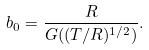Convert formula to latex. <formula><loc_0><loc_0><loc_500><loc_500>b _ { 0 } = \frac { R } { G ( ( T / R ) ^ { 1 / 2 } ) } .</formula> 